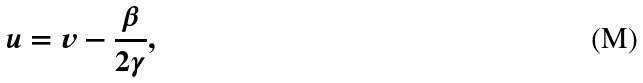Convert formula to latex. <formula><loc_0><loc_0><loc_500><loc_500>u = v - \frac { \beta } { 2 \gamma } ,</formula> 